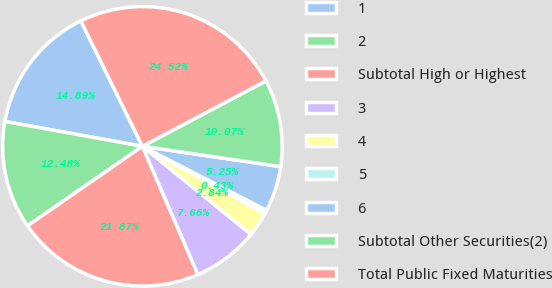Convert chart. <chart><loc_0><loc_0><loc_500><loc_500><pie_chart><fcel>1<fcel>2<fcel>Subtotal High or Highest<fcel>3<fcel>4<fcel>5<fcel>6<fcel>Subtotal Other Securities(2)<fcel>Total Public Fixed Maturities<nl><fcel>14.89%<fcel>12.48%<fcel>21.87%<fcel>7.66%<fcel>2.84%<fcel>0.43%<fcel>5.25%<fcel>10.07%<fcel>24.52%<nl></chart> 